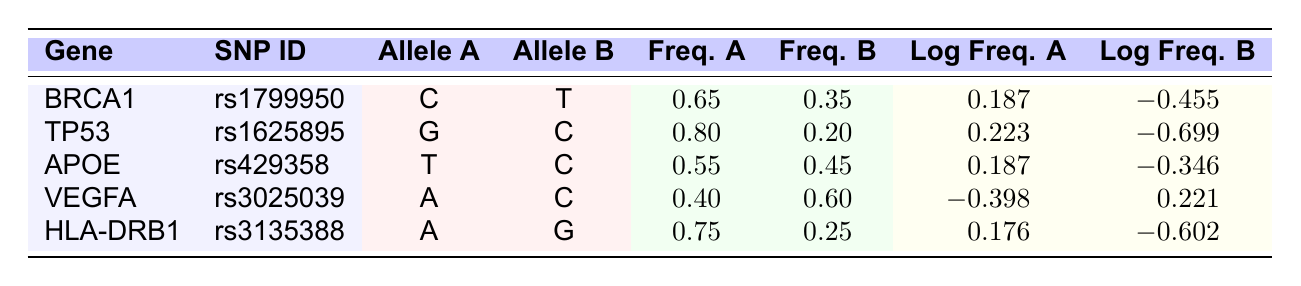What is the frequency of Allele A for SNP ID rs1799950 in the BRCA1 gene? The table shows the frequency of Allele A for SNP ID rs1799950, which is 0.65 in the BRCA1 gene.
Answer: 0.65 Which SNP has the highest frequency of Allele B? By comparing Frequency B values across the table, rs3025039 has the highest frequency of Allele B at 0.60.
Answer: rs3025039 What is the log frequency difference between Allele A and Allele B for the TP53 gene? The log frequency for Allele A (0.223) minus the log frequency for Allele B (-0.699) is 0.223 - (-0.699) = 0.922.
Answer: 0.922 Is the frequency of Allele A greater than the frequency of Allele B for all SNPs listed? Three SNPs (BRCA1, TP53, HLA-DRB1) have a greater frequency of Allele A than Allele B, while APOE has nearly equal frequencies, and VEGFA has a greater frequency for Allele B. Thus, this statement is false.
Answer: No What is the average frequency of Allele A across all SNPs? The frequencies of Allele A are: 0.65, 0.80, 0.55, 0.40, and 0.75. The sum is 0.65 + 0.80 + 0.55 + 0.40 + 0.75 = 3.15. Dividing this by the number of SNPs (5) gives an average frequency of 3.15/5 = 0.63.
Answer: 0.63 Which gene has the lowest log frequency for Allele A? Looking at the Log Frequency A values, the lowest value is -0.398 for the VEGFA gene.
Answer: VEGFA How many SNPs have a Log Frequency B that is positive? Only one SNP, which is rs3025039 (VEGFA), has a positive log frequency for Allele B, which is 0.221.
Answer: 1 What is the log frequency of Allele B for the SNP with the highest Frequency A? The SNP with the highest Frequency A is for TP53 (0.80). The log frequency for Allele B for TP53 is -0.699.
Answer: -0.699 